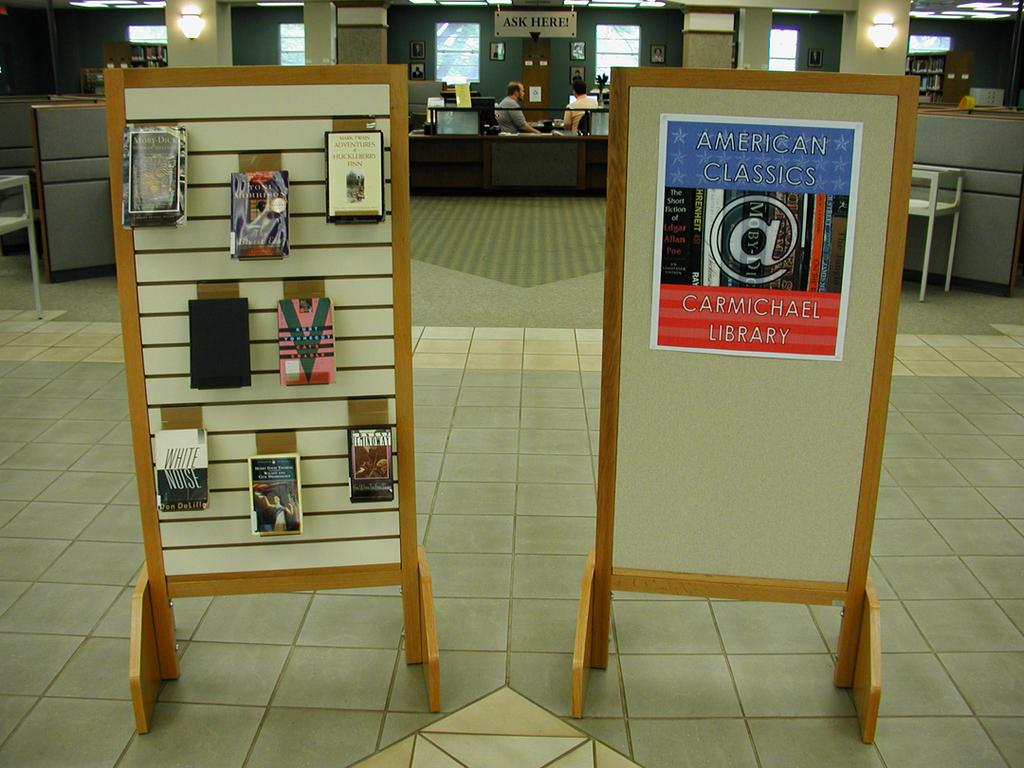Provide a one-sentence caption for the provided image. 2 wooden stand up pallets that has American Classics sign Carmichael Library. 